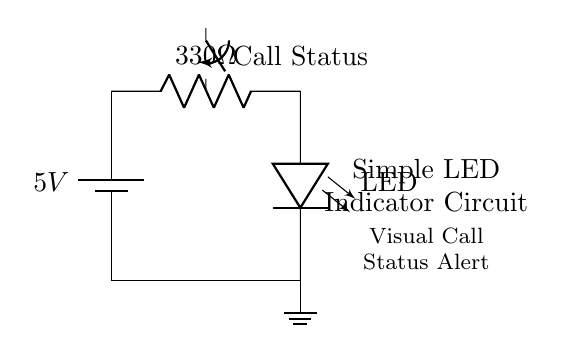What is the voltage of this circuit? The voltage of the circuit is specified as 5V, which is indicated by the battery component in the circuit diagram. This is the source voltage providing power to the circuit.
Answer: 5V What type of switch is used in the circuit? The switch in the circuit is labeled as a closing switch, indicating that it can complete the circuit and allow current to flow when closed. This is further confirmed by the symbol used in the circuit.
Answer: Closing switch What is the resistance value in this circuit? The resistance value in the circuit is given as 330 ohms, which is shown next to the resistor in the circuit diagram. This value limits the current that can flow through the LED to prevent it from burning out.
Answer: 330 ohms Which component emits light in this circuit? The component that emits light in this circuit is the LED, indicated by the symbol labeled as "LED" in the diagram. This component is specifically designed to provide visual indication when powered.
Answer: LED What will happen if the switch is closed? When the switch is closed, the circuit is completed, allowing current to flow from the battery through the resistor and LED, causing the LED to light up. This visual signal indicates the call status is active.
Answer: LED lights up How is the LED connected in this circuit? The LED is connected between the output of the resistor and ground, creating a parallel path for current to flow through the LED when the switch is closed, ensuring proper operation of the indicator.
Answer: In series with a resistor 